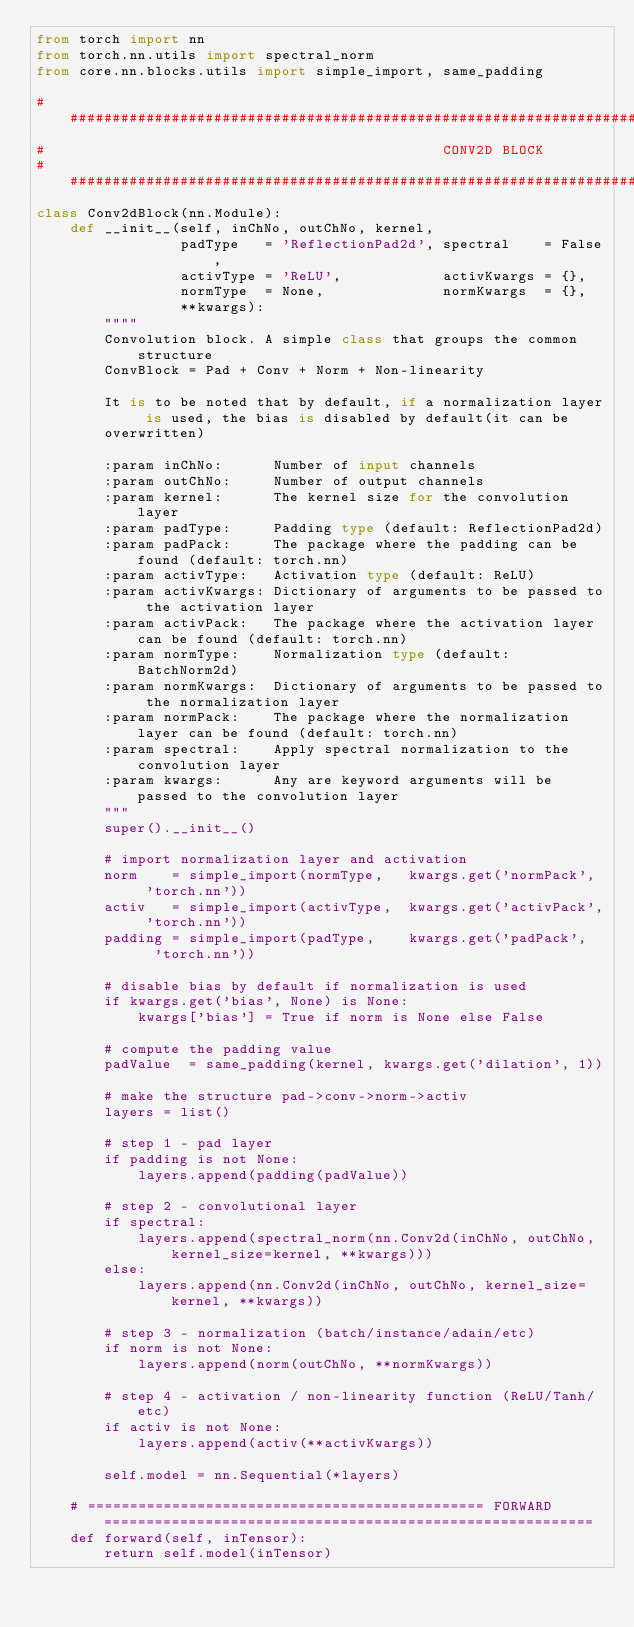Convert code to text. <code><loc_0><loc_0><loc_500><loc_500><_Python_>from torch import nn
from torch.nn.utils import spectral_norm
from core.nn.blocks.utils import simple_import, same_padding

# ######################################################################################################################
#                                               CONV2D BLOCK
# ######################################################################################################################
class Conv2dBlock(nn.Module):
    def __init__(self, inChNo, outChNo, kernel,
                 padType   = 'ReflectionPad2d', spectral    = False,
                 activType = 'ReLU',            activKwargs = {},
                 normType  = None,              normKwargs  = {},
                 **kwargs):
        """"
        Convolution block. A simple class that groups the common structure
        ConvBlock = Pad + Conv + Norm + Non-linearity

        It is to be noted that by default, if a normalization layer is used, the bias is disabled by default(it can be
        overwritten)

        :param inChNo:      Number of input channels
        :param outChNo:     Number of output channels
        :param kernel:      The kernel size for the convolution layer
        :param padType:     Padding type (default: ReflectionPad2d)
        :param padPack:     The package where the padding can be found (default: torch.nn)
        :param activType:   Activation type (default: ReLU)
        :param activKwargs: Dictionary of arguments to be passed to the activation layer
        :param activPack:   The package where the activation layer can be found (default: torch.nn)
        :param normType:    Normalization type (default: BatchNorm2d)
        :param normKwargs:  Dictionary of arguments to be passed to the normalization layer
        :param normPack:    The package where the normalization layer can be found (default: torch.nn)
        :param spectral:    Apply spectral normalization to the convolution layer
        :param kwargs:      Any are keyword arguments will be passed to the convolution layer
        """
        super().__init__()

        # import normalization layer and activation
        norm    = simple_import(normType,   kwargs.get('normPack',  'torch.nn'))
        activ   = simple_import(activType,  kwargs.get('activPack', 'torch.nn'))
        padding = simple_import(padType,    kwargs.get('padPack',   'torch.nn'))

        # disable bias by default if normalization is used
        if kwargs.get('bias', None) is None:
            kwargs['bias'] = True if norm is None else False

        # compute the padding value
        padValue  = same_padding(kernel, kwargs.get('dilation', 1))

        # make the structure pad->conv->norm->activ
        layers = list()

        # step 1 - pad layer
        if padding is not None:
            layers.append(padding(padValue))

        # step 2 - convolutional layer
        if spectral:
            layers.append(spectral_norm(nn.Conv2d(inChNo, outChNo, kernel_size=kernel, **kwargs)))
        else:
            layers.append(nn.Conv2d(inChNo, outChNo, kernel_size=kernel, **kwargs))

        # step 3 - normalization (batch/instance/adain/etc)
        if norm is not None:
            layers.append(norm(outChNo, **normKwargs))

        # step 4 - activation / non-linearity function (ReLU/Tanh/etc)
        if activ is not None:
            layers.append(activ(**activKwargs))

        self.model = nn.Sequential(*layers)

    # =============================================== FORWARD ==========================================================
    def forward(self, inTensor):
        return self.model(inTensor)</code> 